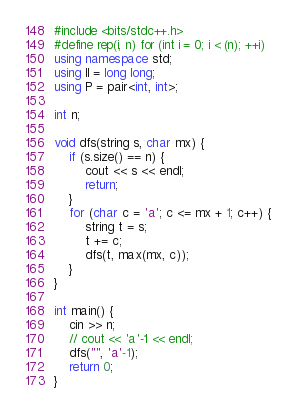<code> <loc_0><loc_0><loc_500><loc_500><_C++_>#include <bits/stdc++.h>
#define rep(i, n) for (int i = 0; i < (n); ++i)
using namespace std;
using ll = long long;
using P = pair<int, int>;

int n;

void dfs(string s, char mx) {
    if (s.size() == n) {
        cout << s << endl;
        return;
    }
    for (char c = 'a'; c <= mx + 1; c++) {
        string t = s;
        t += c;
        dfs(t, max(mx, c));
    }
}

int main() { 
    cin >> n;
    // cout << 'a'-1 << endl;
    dfs("", 'a'-1);
    return 0;
}
</code> 